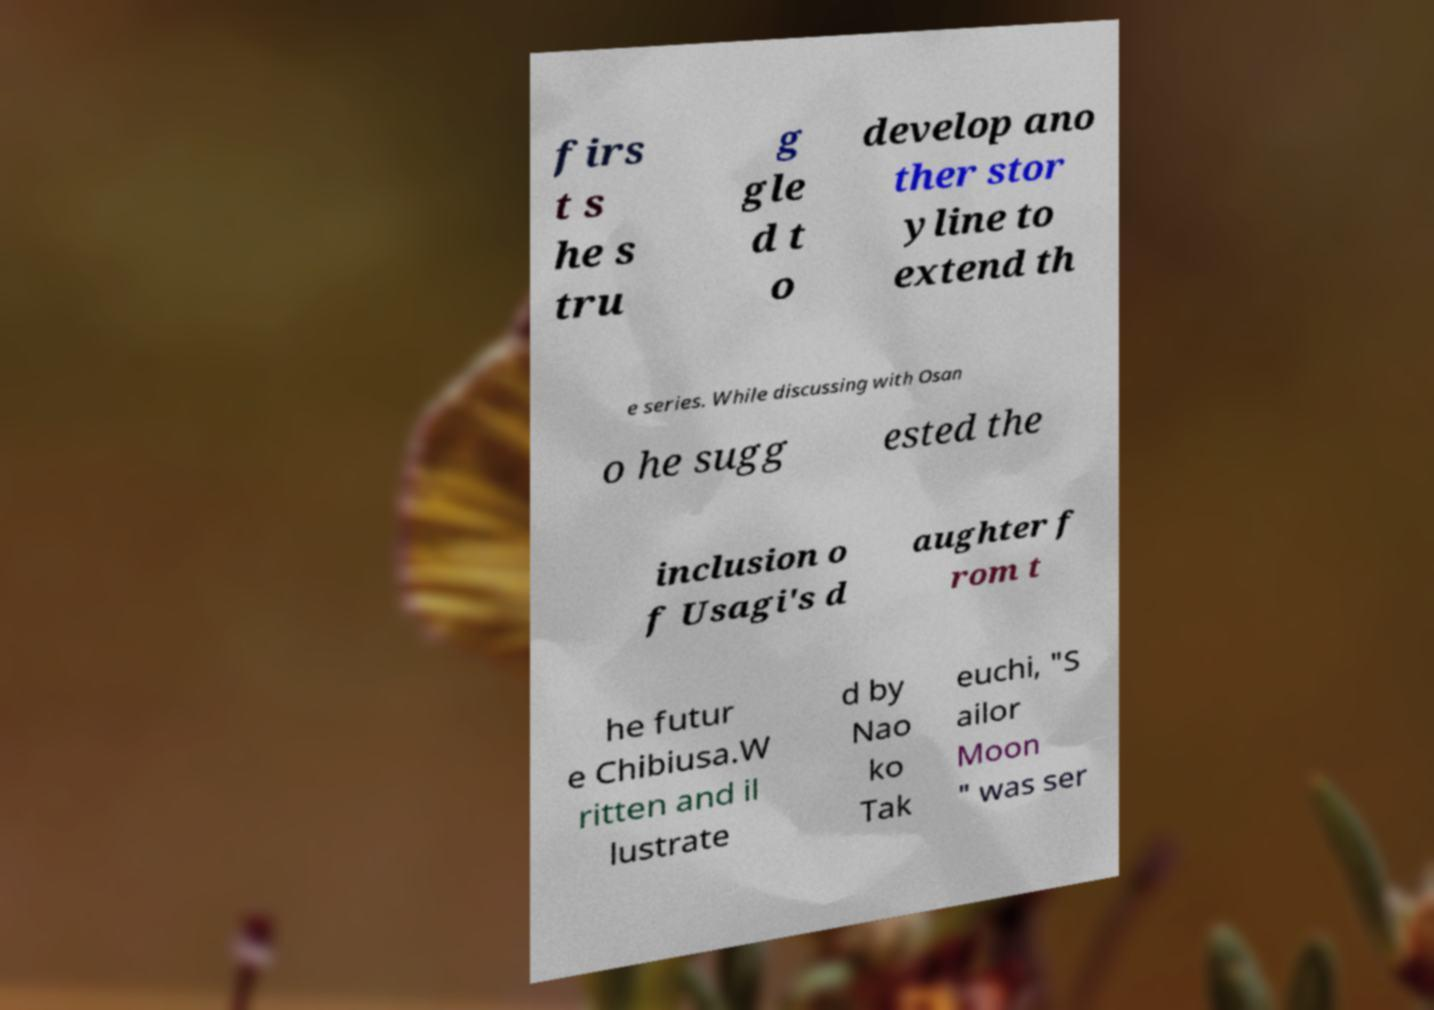For documentation purposes, I need the text within this image transcribed. Could you provide that? firs t s he s tru g gle d t o develop ano ther stor yline to extend th e series. While discussing with Osan o he sugg ested the inclusion o f Usagi's d aughter f rom t he futur e Chibiusa.W ritten and il lustrate d by Nao ko Tak euchi, "S ailor Moon " was ser 